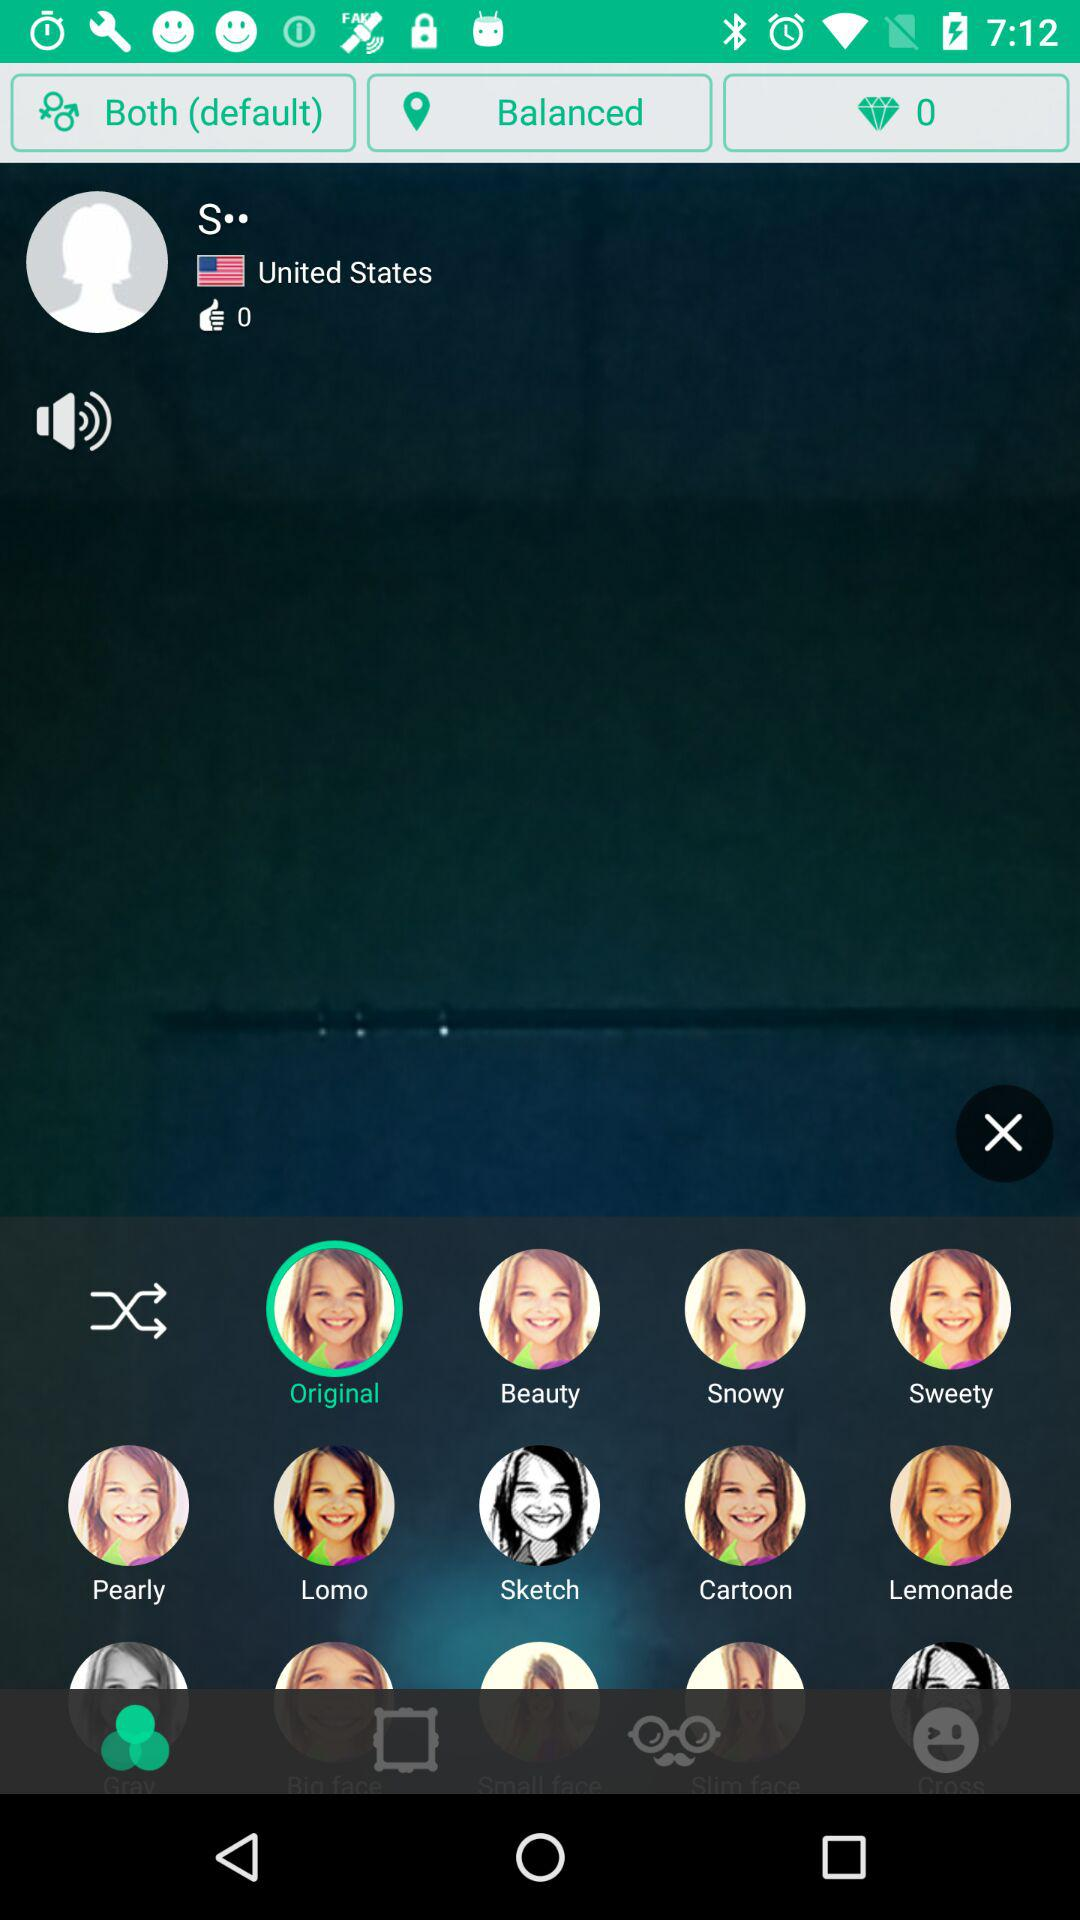What is the country name? The country name is the United States. 